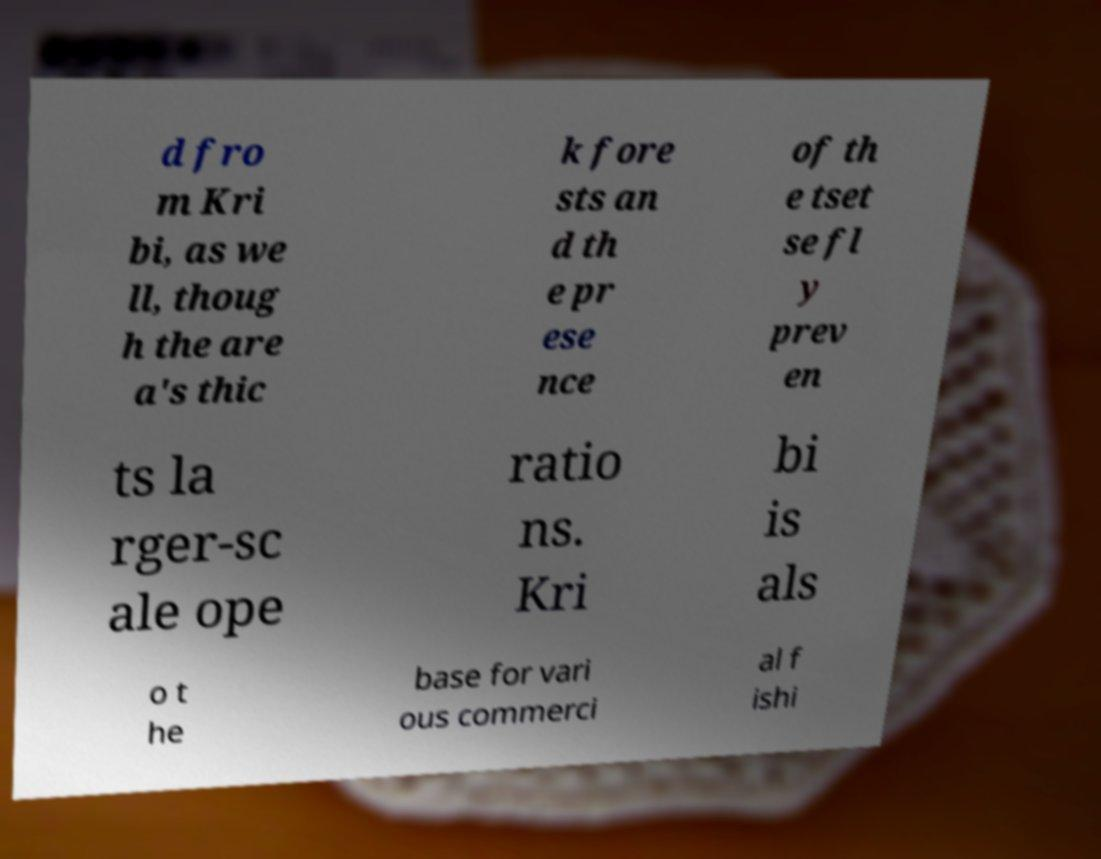Please identify and transcribe the text found in this image. d fro m Kri bi, as we ll, thoug h the are a's thic k fore sts an d th e pr ese nce of th e tset se fl y prev en ts la rger-sc ale ope ratio ns. Kri bi is als o t he base for vari ous commerci al f ishi 